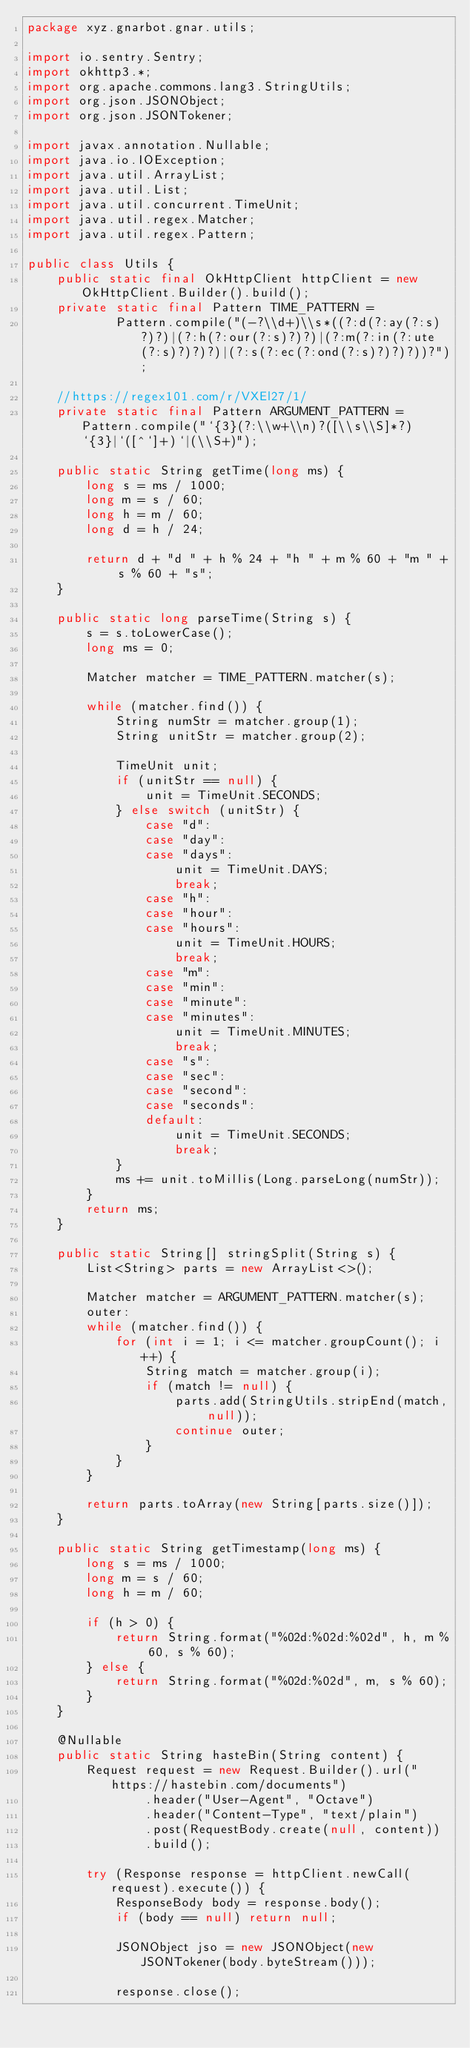Convert code to text. <code><loc_0><loc_0><loc_500><loc_500><_Java_>package xyz.gnarbot.gnar.utils;

import io.sentry.Sentry;
import okhttp3.*;
import org.apache.commons.lang3.StringUtils;
import org.json.JSONObject;
import org.json.JSONTokener;

import javax.annotation.Nullable;
import java.io.IOException;
import java.util.ArrayList;
import java.util.List;
import java.util.concurrent.TimeUnit;
import java.util.regex.Matcher;
import java.util.regex.Pattern;

public class Utils {
    public static final OkHttpClient httpClient = new OkHttpClient.Builder().build();
    private static final Pattern TIME_PATTERN =
            Pattern.compile("(-?\\d+)\\s*((?:d(?:ay(?:s)?)?)|(?:h(?:our(?:s)?)?)|(?:m(?:in(?:ute(?:s)?)?)?)|(?:s(?:ec(?:ond(?:s)?)?)?))?");

    //https://regex101.com/r/VXEl27/1/
    private static final Pattern ARGUMENT_PATTERN = Pattern.compile("`{3}(?:\\w+\\n)?([\\s\\S]*?)`{3}|`([^`]+)`|(\\S+)");

    public static String getTime(long ms) {
        long s = ms / 1000;
        long m = s / 60;
        long h = m / 60;
        long d = h / 24;

        return d + "d " + h % 24 + "h " + m % 60 + "m " + s % 60 + "s";
    }

    public static long parseTime(String s) {
        s = s.toLowerCase();
        long ms = 0;

        Matcher matcher = TIME_PATTERN.matcher(s);

        while (matcher.find()) {
            String numStr = matcher.group(1);
            String unitStr = matcher.group(2);

            TimeUnit unit;
            if (unitStr == null) {
                unit = TimeUnit.SECONDS;
            } else switch (unitStr) {
                case "d":
                case "day":
                case "days":
                    unit = TimeUnit.DAYS;
                    break;
                case "h":
                case "hour":
                case "hours":
                    unit = TimeUnit.HOURS;
                    break;
                case "m":
                case "min":
                case "minute":
                case "minutes":
                    unit = TimeUnit.MINUTES;
                    break;
                case "s":
                case "sec":
                case "second":
                case "seconds":
                default:
                    unit = TimeUnit.SECONDS;
                    break;
            }
            ms += unit.toMillis(Long.parseLong(numStr));
        }
        return ms;
    }

    public static String[] stringSplit(String s) {
        List<String> parts = new ArrayList<>();

        Matcher matcher = ARGUMENT_PATTERN.matcher(s);
        outer:
        while (matcher.find()) {
            for (int i = 1; i <= matcher.groupCount(); i++) {
                String match = matcher.group(i);
                if (match != null) {
                    parts.add(StringUtils.stripEnd(match, null));
                    continue outer;
                }
            }
        }

        return parts.toArray(new String[parts.size()]);
    }

    public static String getTimestamp(long ms) {
        long s = ms / 1000;
        long m = s / 60;
        long h = m / 60;

        if (h > 0) {
            return String.format("%02d:%02d:%02d", h, m % 60, s % 60);
        } else {
            return String.format("%02d:%02d", m, s % 60);
        }
    }

    @Nullable
    public static String hasteBin(String content) {
        Request request = new Request.Builder().url("https://hastebin.com/documents")
                .header("User-Agent", "Octave")
                .header("Content-Type", "text/plain")
                .post(RequestBody.create(null, content))
                .build();

        try (Response response = httpClient.newCall(request).execute()) {
            ResponseBody body = response.body();
            if (body == null) return null;

            JSONObject jso = new JSONObject(new JSONTokener(body.byteStream()));

            response.close();
</code> 